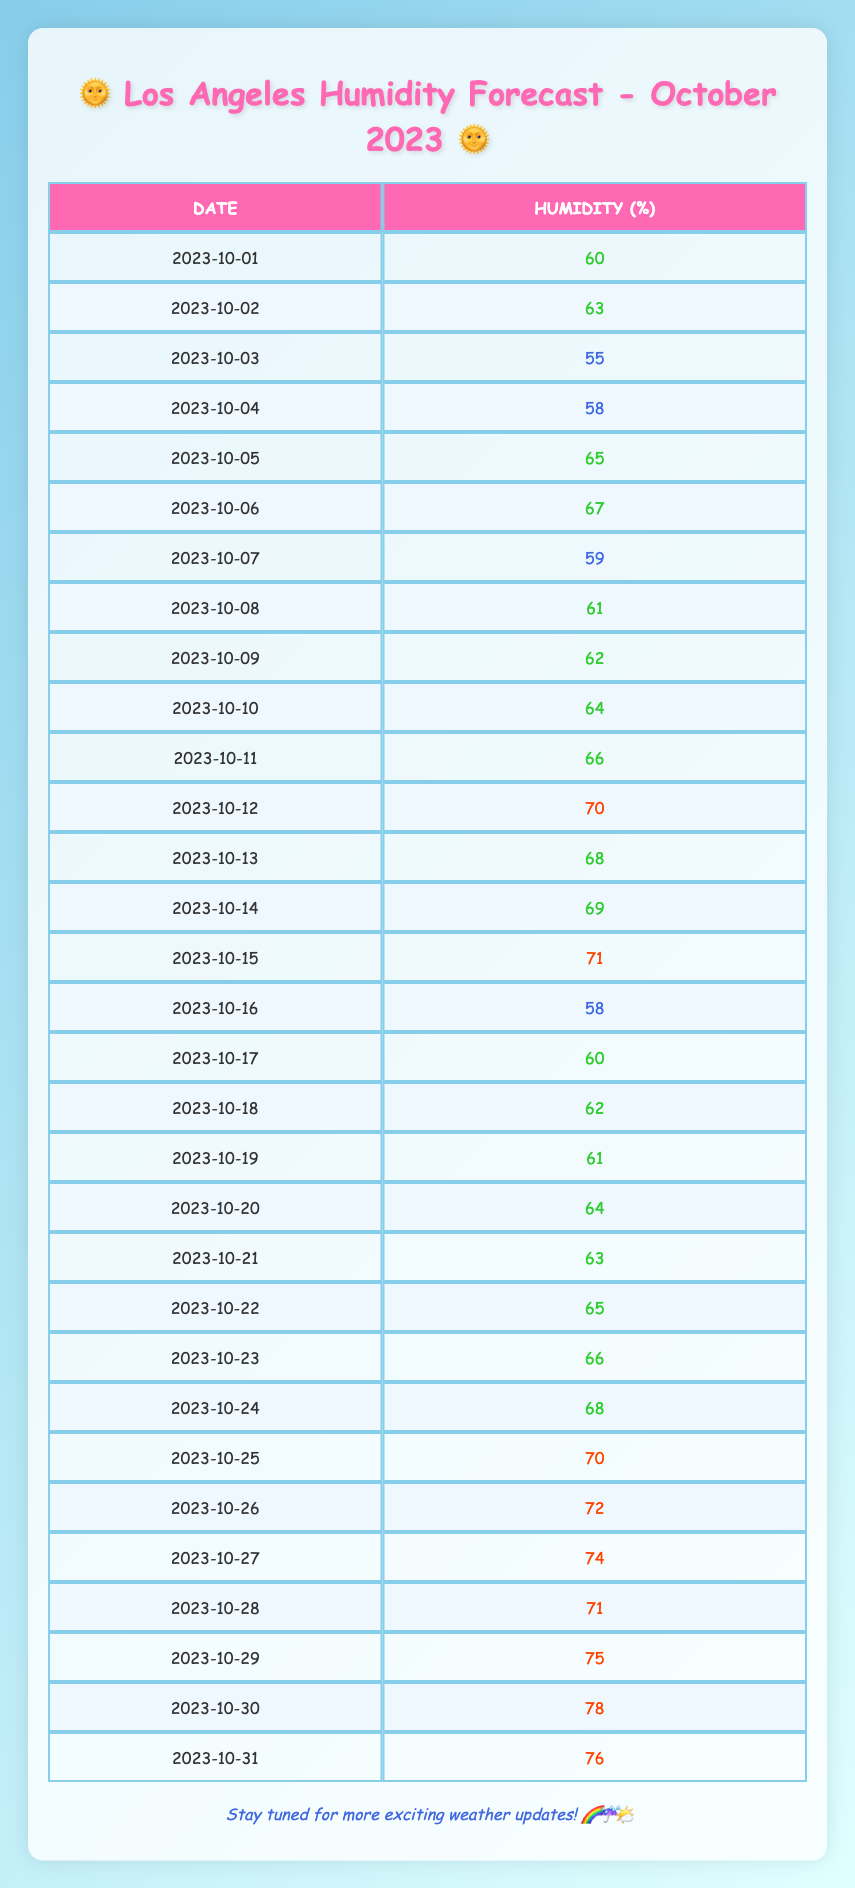What was the maximum humidity recorded in Los Angeles in October 2023? The maximum humidity recorded from the table is 78%, observed on October 30.
Answer: 78% What was the minimum humidity in October 2023? The minimum humidity recorded is 55%, which occurred on October 3.
Answer: 55% How many days had humidity levels above 70%? There are 8 days with humidity levels above 70%: October 12, 15, 25, 26, 27, 28, 29, and 30.
Answer: 8 What is the average humidity for the month of October 2023? To calculate the average, we sum all daily humidity levels: 60 + 63 + 55 + 58 + 65 + 67 + 59 + 61 + 62 + 64 + 66 + 70 + 68 + 69 + 71 + 58 + 60 + 62 + 61 + 64 + 63 + 65 + 66 + 68 + 70 + 72 + 74 + 71 + 75 + 78 + 76 = 1979. There are 31 days, so the average is 1979 / 31 = 63.9.
Answer: 63.9 Did the humidity levels ever drop below 60%? Yes, there were five days when the humidity dropped below 60%: October 3, 4, 7, and 16.
Answer: Yes On which date was the humidity recorded at 75%? The humidity reached 75% on October 29.
Answer: October 29 How does the humidity level on October 18 compare to the average humidity level for the month? The humidity on October 18 is 62%, which is below the average of 63.9% for the month of October 2023.
Answer: Below average Which date had the most significant increase in humidity compared to the previous day? The most significant increase occurred from October 29 (75%) to October 30 (78%), a difference of 3%.
Answer: October 30 What was the average humidity during the second half of the month (October 16 to October 31)? The sum of humidity from October 16 to 31 is 58 + 60 + 62 + 61 + 64 + 63 + 65 + 66 + 68 + 70 + 72 + 74 + 71 + 75 + 78 + 76 = 1068. There are 16 days in the second half, so the average is 1068 / 16 = 66.75.
Answer: 66.75 